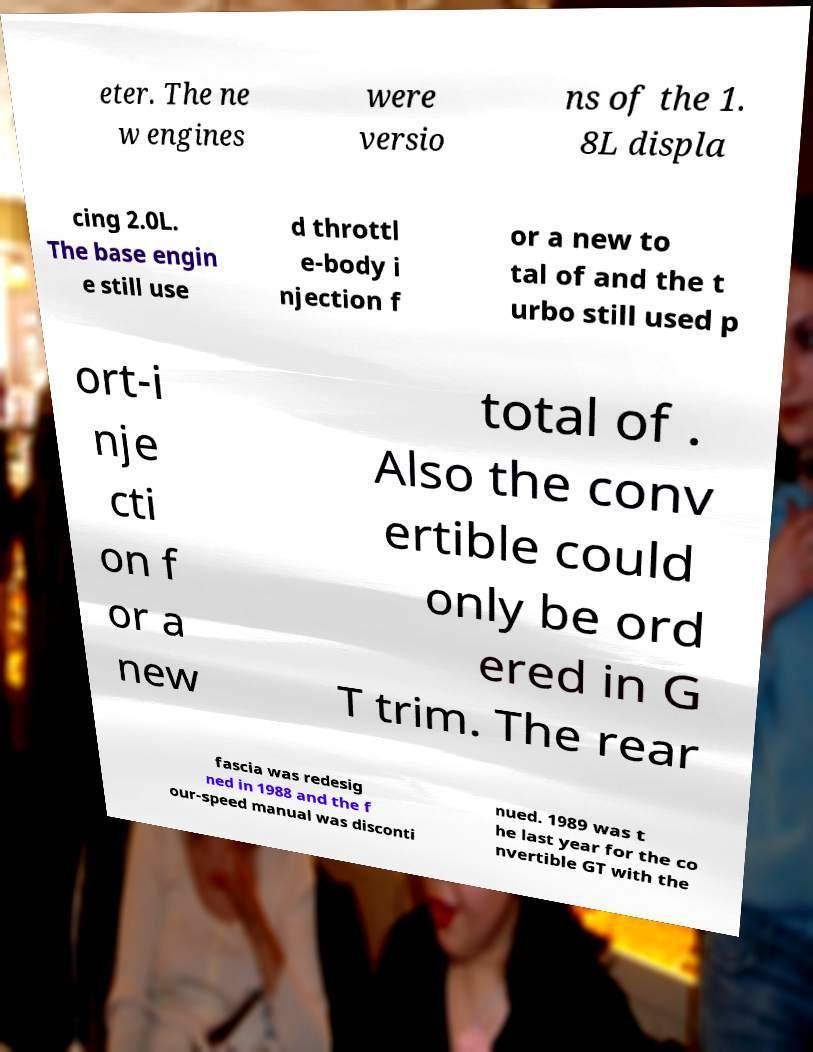Can you read and provide the text displayed in the image?This photo seems to have some interesting text. Can you extract and type it out for me? eter. The ne w engines were versio ns of the 1. 8L displa cing 2.0L. The base engin e still use d throttl e-body i njection f or a new to tal of and the t urbo still used p ort-i nje cti on f or a new total of . Also the conv ertible could only be ord ered in G T trim. The rear fascia was redesig ned in 1988 and the f our-speed manual was disconti nued. 1989 was t he last year for the co nvertible GT with the 